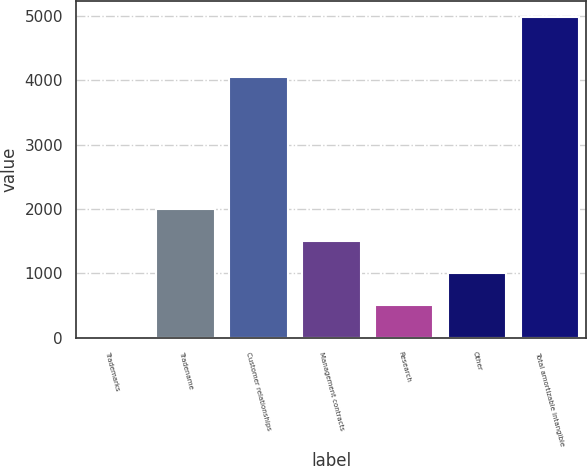<chart> <loc_0><loc_0><loc_500><loc_500><bar_chart><fcel>Trademarks<fcel>Tradename<fcel>Customer relationships<fcel>Management contracts<fcel>Research<fcel>Other<fcel>Total amortizable intangible<nl><fcel>7<fcel>1996.6<fcel>4058<fcel>1499.2<fcel>504.4<fcel>1001.8<fcel>4981<nl></chart> 